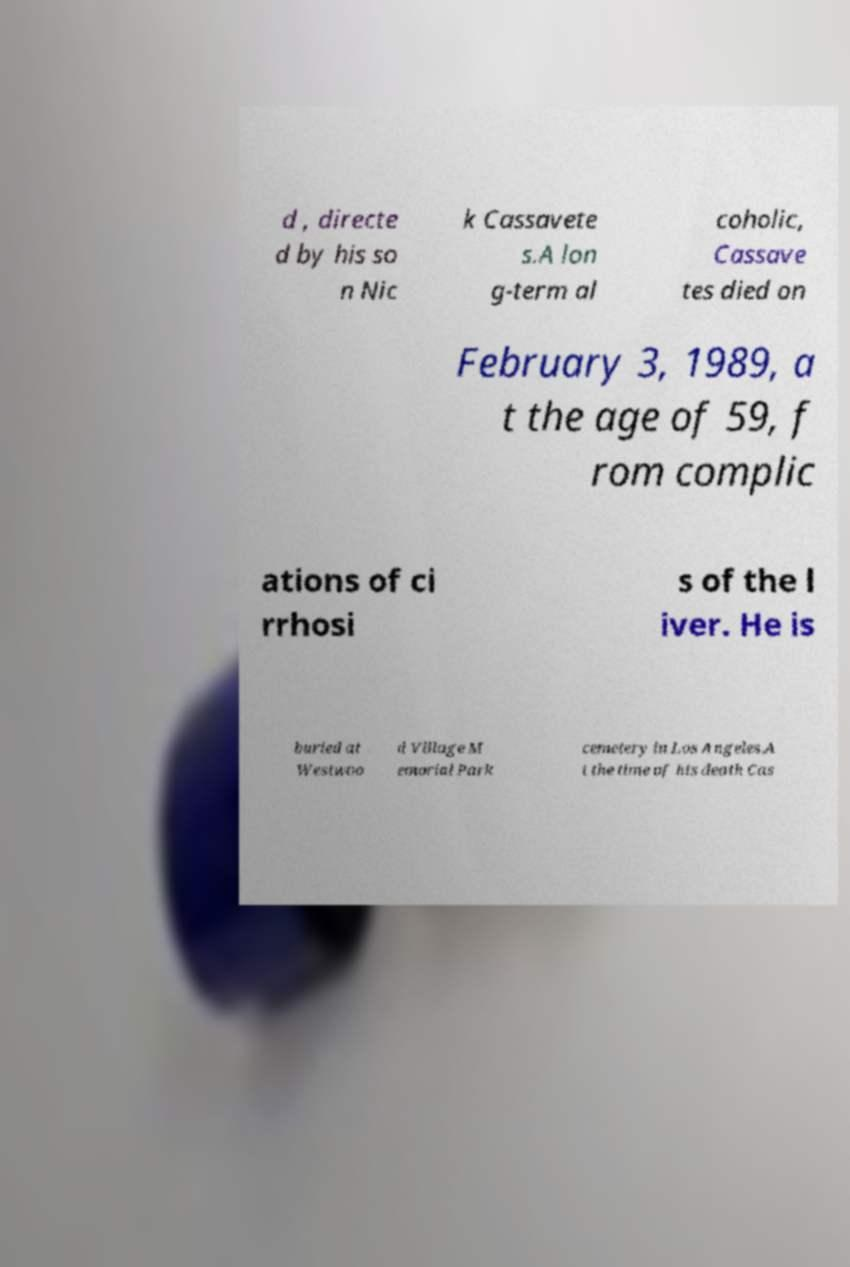What messages or text are displayed in this image? I need them in a readable, typed format. d , directe d by his so n Nic k Cassavete s.A lon g-term al coholic, Cassave tes died on February 3, 1989, a t the age of 59, f rom complic ations of ci rrhosi s of the l iver. He is buried at Westwoo d Village M emorial Park cemetery in Los Angeles.A t the time of his death Cas 